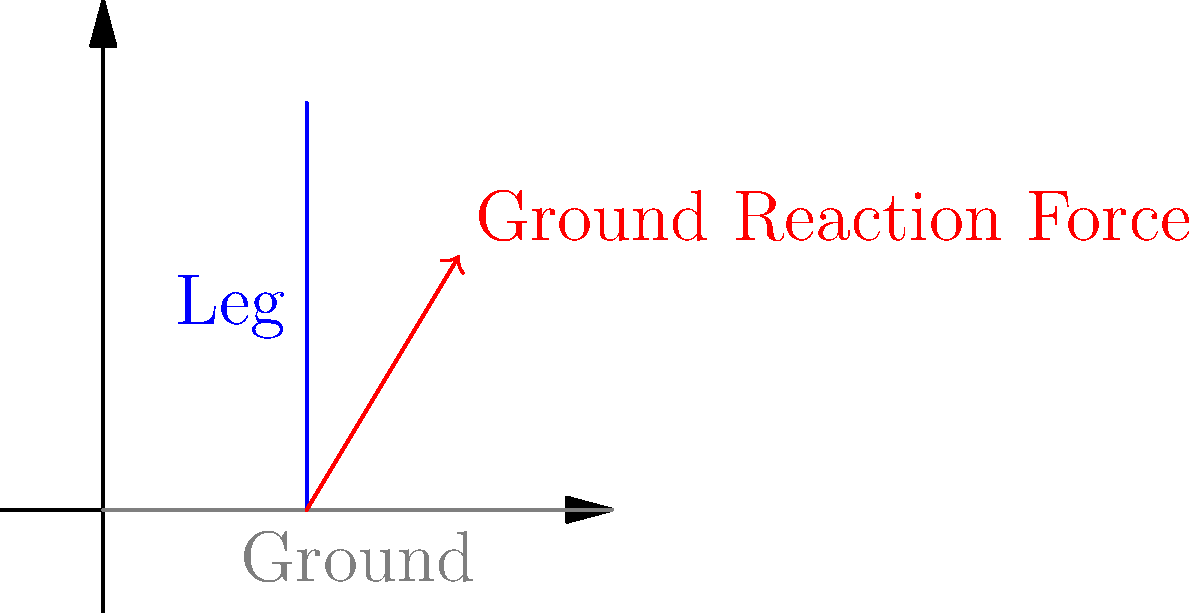Based on the force vector illustration, which joint in an elite marathon runner's lower extremity is likely to experience the highest impact forces during foot strike, and why? To determine which joint experiences the highest impact forces during foot strike, let's analyze the biomechanics step-by-step:

1. Ground Reaction Force (GRF): The illustration shows a force vector pointing upward and slightly forward, representing the GRF during foot strike.

2. Force Transmission: This force is transmitted up the leg, affecting multiple joints.

3. Joint Analysis:
   a) Ankle: The first joint to receive the impact, but it has some shock-absorbing capabilities through the plantar fascia and Achilles tendon.
   b) Knee: Receives force transmitted through the ankle, with less natural shock absorption.
   c) Hip: The most proximal joint, receiving accumulated forces from both ankle and knee.

4. Lever Arm: The hip joint has the longest lever arm from the point of impact, potentially increasing the moment of force acting on it.

5. Running Biomechanics: Elite marathon runners often have a midfoot or forefoot strike, which can increase loading rates and peak forces.

6. Repetitive Impact: Over the course of a marathon, the cumulative effect of these forces is significant, particularly on the joint with the highest load.

7. Research Findings: Studies have shown that the hip joint often experiences the highest peak forces during running, sometimes exceeding 5 times body weight.

Given these factors, the hip joint is likely to experience the highest impact forces. Its position at the top of the kinetic chain, combined with the longest lever arm and the cumulative effect of forces transmitted through the ankle and knee, makes it most susceptible to high impact loads during foot strike in elite marathon running.
Answer: Hip joint, due to cumulative force transmission and longest lever arm. 